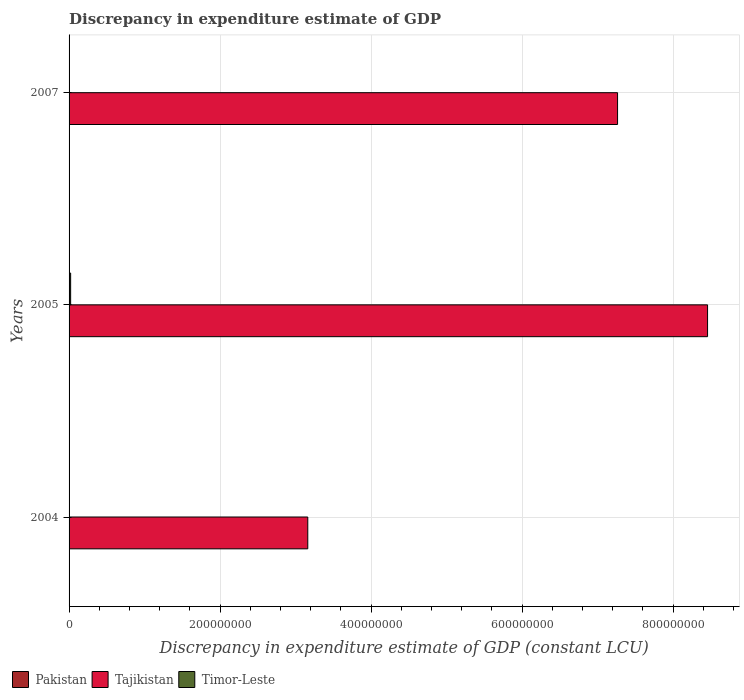What is the label of the 2nd group of bars from the top?
Keep it short and to the point. 2005. In how many cases, is the number of bars for a given year not equal to the number of legend labels?
Provide a succinct answer. 3. What is the discrepancy in expenditure estimate of GDP in Timor-Leste in 2004?
Provide a succinct answer. 8.88e+04. Across all years, what is the maximum discrepancy in expenditure estimate of GDP in Tajikistan?
Make the answer very short. 8.46e+08. What is the total discrepancy in expenditure estimate of GDP in Tajikistan in the graph?
Your answer should be very brief. 1.89e+09. What is the difference between the discrepancy in expenditure estimate of GDP in Tajikistan in 2005 and that in 2007?
Your answer should be compact. 1.19e+08. What is the difference between the discrepancy in expenditure estimate of GDP in Tajikistan in 2004 and the discrepancy in expenditure estimate of GDP in Pakistan in 2005?
Keep it short and to the point. 3.16e+08. What is the average discrepancy in expenditure estimate of GDP in Pakistan per year?
Your answer should be compact. 0. In the year 2005, what is the difference between the discrepancy in expenditure estimate of GDP in Tajikistan and discrepancy in expenditure estimate of GDP in Timor-Leste?
Your response must be concise. 8.44e+08. What is the ratio of the discrepancy in expenditure estimate of GDP in Timor-Leste in 2004 to that in 2005?
Give a very brief answer. 0.04. Is the difference between the discrepancy in expenditure estimate of GDP in Tajikistan in 2004 and 2005 greater than the difference between the discrepancy in expenditure estimate of GDP in Timor-Leste in 2004 and 2005?
Your response must be concise. No. What is the difference between the highest and the second highest discrepancy in expenditure estimate of GDP in Tajikistan?
Offer a very short reply. 1.19e+08. What is the difference between the highest and the lowest discrepancy in expenditure estimate of GDP in Tajikistan?
Offer a terse response. 5.29e+08. Is the sum of the discrepancy in expenditure estimate of GDP in Tajikistan in 2004 and 2007 greater than the maximum discrepancy in expenditure estimate of GDP in Timor-Leste across all years?
Give a very brief answer. Yes. What is the title of the graph?
Offer a terse response. Discrepancy in expenditure estimate of GDP. Does "Aruba" appear as one of the legend labels in the graph?
Give a very brief answer. No. What is the label or title of the X-axis?
Your answer should be compact. Discrepancy in expenditure estimate of GDP (constant LCU). What is the Discrepancy in expenditure estimate of GDP (constant LCU) in Tajikistan in 2004?
Give a very brief answer. 3.16e+08. What is the Discrepancy in expenditure estimate of GDP (constant LCU) of Timor-Leste in 2004?
Provide a short and direct response. 8.88e+04. What is the Discrepancy in expenditure estimate of GDP (constant LCU) in Tajikistan in 2005?
Ensure brevity in your answer.  8.46e+08. What is the Discrepancy in expenditure estimate of GDP (constant LCU) of Timor-Leste in 2005?
Keep it short and to the point. 2.08e+06. What is the Discrepancy in expenditure estimate of GDP (constant LCU) in Tajikistan in 2007?
Keep it short and to the point. 7.26e+08. What is the Discrepancy in expenditure estimate of GDP (constant LCU) in Timor-Leste in 2007?
Your answer should be compact. 0. Across all years, what is the maximum Discrepancy in expenditure estimate of GDP (constant LCU) in Tajikistan?
Ensure brevity in your answer.  8.46e+08. Across all years, what is the maximum Discrepancy in expenditure estimate of GDP (constant LCU) in Timor-Leste?
Make the answer very short. 2.08e+06. Across all years, what is the minimum Discrepancy in expenditure estimate of GDP (constant LCU) of Tajikistan?
Offer a very short reply. 3.16e+08. Across all years, what is the minimum Discrepancy in expenditure estimate of GDP (constant LCU) in Timor-Leste?
Make the answer very short. 0. What is the total Discrepancy in expenditure estimate of GDP (constant LCU) in Pakistan in the graph?
Give a very brief answer. 0. What is the total Discrepancy in expenditure estimate of GDP (constant LCU) of Tajikistan in the graph?
Provide a succinct answer. 1.89e+09. What is the total Discrepancy in expenditure estimate of GDP (constant LCU) in Timor-Leste in the graph?
Give a very brief answer. 2.17e+06. What is the difference between the Discrepancy in expenditure estimate of GDP (constant LCU) of Tajikistan in 2004 and that in 2005?
Give a very brief answer. -5.29e+08. What is the difference between the Discrepancy in expenditure estimate of GDP (constant LCU) of Timor-Leste in 2004 and that in 2005?
Your answer should be compact. -1.99e+06. What is the difference between the Discrepancy in expenditure estimate of GDP (constant LCU) of Tajikistan in 2004 and that in 2007?
Your answer should be compact. -4.10e+08. What is the difference between the Discrepancy in expenditure estimate of GDP (constant LCU) in Tajikistan in 2005 and that in 2007?
Ensure brevity in your answer.  1.19e+08. What is the difference between the Discrepancy in expenditure estimate of GDP (constant LCU) of Tajikistan in 2004 and the Discrepancy in expenditure estimate of GDP (constant LCU) of Timor-Leste in 2005?
Your answer should be very brief. 3.14e+08. What is the average Discrepancy in expenditure estimate of GDP (constant LCU) in Tajikistan per year?
Provide a short and direct response. 6.29e+08. What is the average Discrepancy in expenditure estimate of GDP (constant LCU) of Timor-Leste per year?
Provide a short and direct response. 7.24e+05. In the year 2004, what is the difference between the Discrepancy in expenditure estimate of GDP (constant LCU) of Tajikistan and Discrepancy in expenditure estimate of GDP (constant LCU) of Timor-Leste?
Provide a succinct answer. 3.16e+08. In the year 2005, what is the difference between the Discrepancy in expenditure estimate of GDP (constant LCU) in Tajikistan and Discrepancy in expenditure estimate of GDP (constant LCU) in Timor-Leste?
Give a very brief answer. 8.44e+08. What is the ratio of the Discrepancy in expenditure estimate of GDP (constant LCU) of Tajikistan in 2004 to that in 2005?
Provide a short and direct response. 0.37. What is the ratio of the Discrepancy in expenditure estimate of GDP (constant LCU) of Timor-Leste in 2004 to that in 2005?
Offer a terse response. 0.04. What is the ratio of the Discrepancy in expenditure estimate of GDP (constant LCU) of Tajikistan in 2004 to that in 2007?
Provide a short and direct response. 0.44. What is the ratio of the Discrepancy in expenditure estimate of GDP (constant LCU) of Tajikistan in 2005 to that in 2007?
Offer a very short reply. 1.16. What is the difference between the highest and the second highest Discrepancy in expenditure estimate of GDP (constant LCU) of Tajikistan?
Provide a succinct answer. 1.19e+08. What is the difference between the highest and the lowest Discrepancy in expenditure estimate of GDP (constant LCU) of Tajikistan?
Provide a short and direct response. 5.29e+08. What is the difference between the highest and the lowest Discrepancy in expenditure estimate of GDP (constant LCU) of Timor-Leste?
Your answer should be compact. 2.08e+06. 